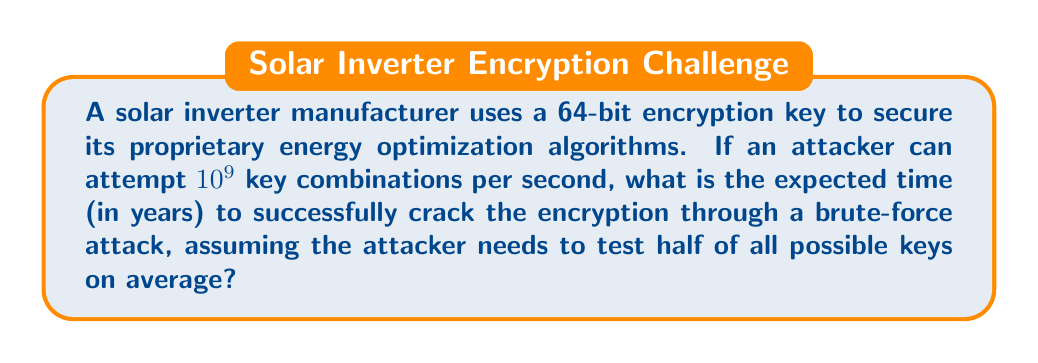Help me with this question. Let's approach this step-by-step:

1) First, we need to calculate the total number of possible 64-bit keys:
   $$2^{64} = 1.8446744 \times 10^{19}$$

2) On average, the attacker needs to test half of all possible keys:
   $$\frac{1.8446744 \times 10^{19}}{2} = 9.2233720 \times 10^{18}$$

3) The attacker can test $10^9$ keys per second. To find the time in seconds:
   $$\frac{9.2233720 \times 10^{18}}{10^9} = 9.2233720 \times 10^9 \text{ seconds}$$

4) Convert seconds to years:
   $$\frac{9.2233720 \times 10^9}{60 \times 60 \times 24 \times 365.25} = 292.471 \text{ years}$$

   Note: We use 365.25 days per year to account for leap years.

5) Therefore, the expected time to crack the encryption is approximately 292.471 years.
Answer: 292.471 years 